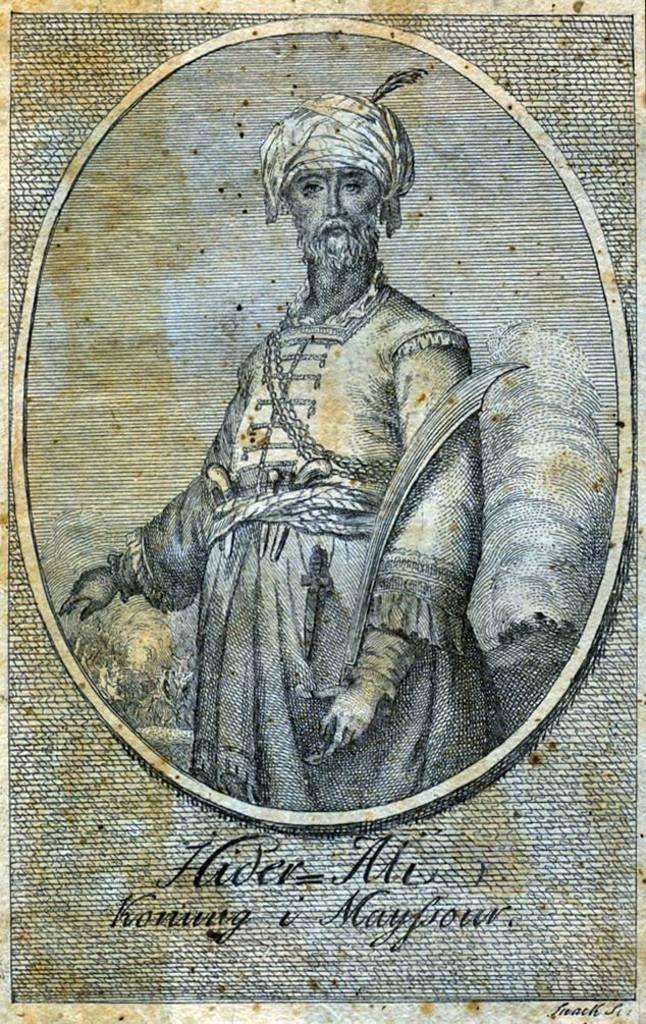Could you give a brief overview of what you see in this image? In this picture we can see a paper, there is a picture of a man on this paper, he is standing, at the bottom there is some text. 